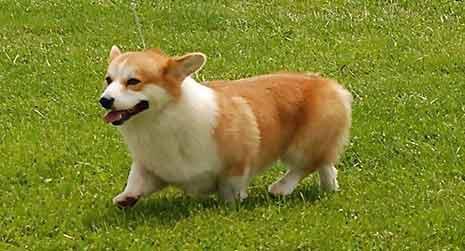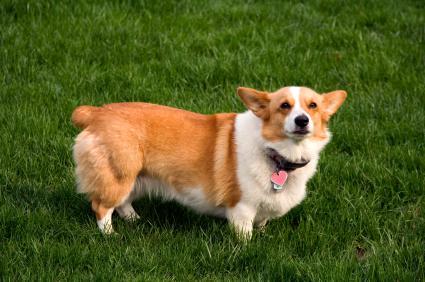The first image is the image on the left, the second image is the image on the right. For the images displayed, is the sentence "The dog on the right is wearing a collar" factually correct? Answer yes or no. Yes. 